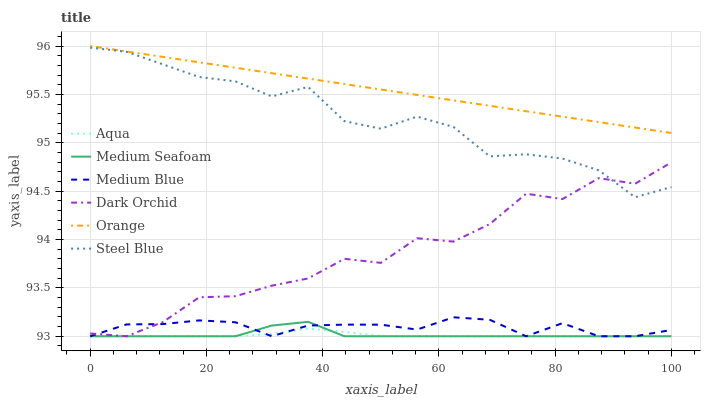Does Aqua have the minimum area under the curve?
Answer yes or no. Yes. Does Orange have the maximum area under the curve?
Answer yes or no. Yes. Does Medium Blue have the minimum area under the curve?
Answer yes or no. No. Does Medium Blue have the maximum area under the curve?
Answer yes or no. No. Is Orange the smoothest?
Answer yes or no. Yes. Is Dark Orchid the roughest?
Answer yes or no. Yes. Is Medium Blue the smoothest?
Answer yes or no. No. Is Medium Blue the roughest?
Answer yes or no. No. Does Aqua have the lowest value?
Answer yes or no. Yes. Does Steel Blue have the lowest value?
Answer yes or no. No. Does Orange have the highest value?
Answer yes or no. Yes. Does Medium Blue have the highest value?
Answer yes or no. No. Is Steel Blue less than Orange?
Answer yes or no. Yes. Is Steel Blue greater than Medium Seafoam?
Answer yes or no. Yes. Does Medium Seafoam intersect Medium Blue?
Answer yes or no. Yes. Is Medium Seafoam less than Medium Blue?
Answer yes or no. No. Is Medium Seafoam greater than Medium Blue?
Answer yes or no. No. Does Steel Blue intersect Orange?
Answer yes or no. No. 